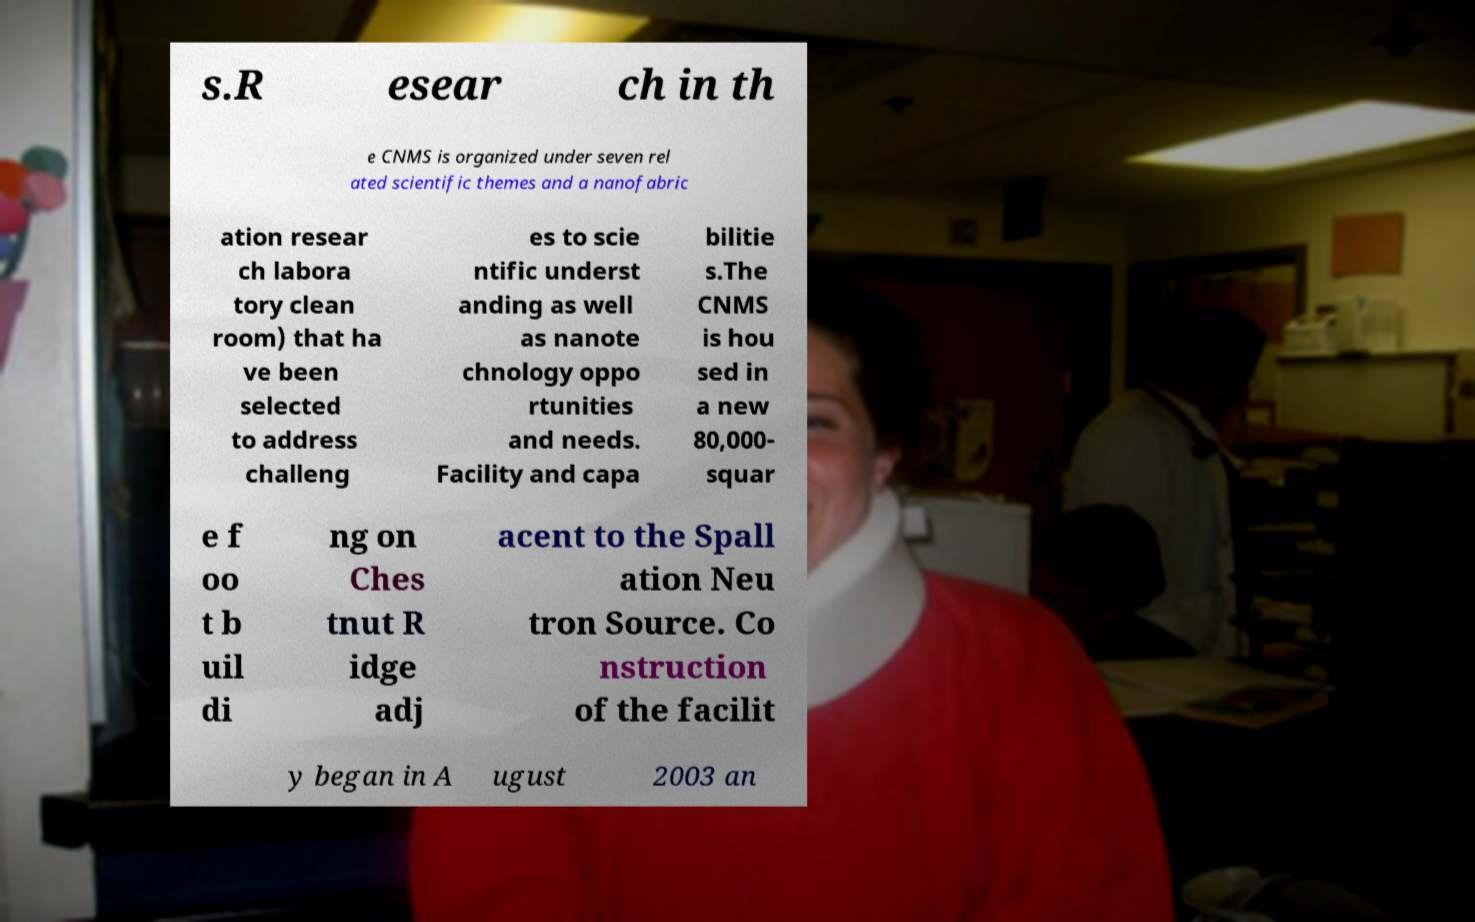Could you assist in decoding the text presented in this image and type it out clearly? s.R esear ch in th e CNMS is organized under seven rel ated scientific themes and a nanofabric ation resear ch labora tory clean room) that ha ve been selected to address challeng es to scie ntific underst anding as well as nanote chnology oppo rtunities and needs. Facility and capa bilitie s.The CNMS is hou sed in a new 80,000- squar e f oo t b uil di ng on Ches tnut R idge adj acent to the Spall ation Neu tron Source. Co nstruction of the facilit y began in A ugust 2003 an 